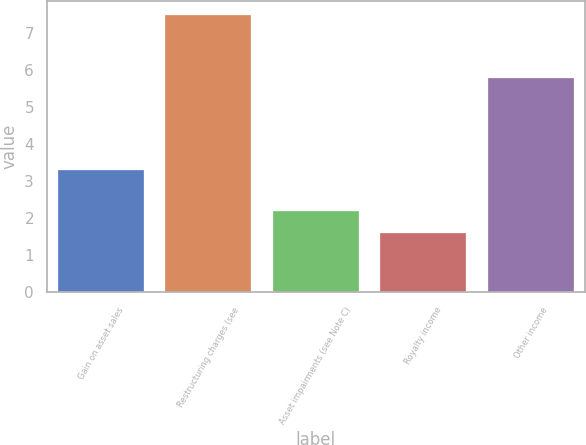Convert chart. <chart><loc_0><loc_0><loc_500><loc_500><bar_chart><fcel>Gain on asset sales<fcel>Restructuring charges (see<fcel>Asset impairments (see Note C)<fcel>Royalty income<fcel>Other income<nl><fcel>3.3<fcel>7.5<fcel>2.19<fcel>1.6<fcel>5.8<nl></chart> 